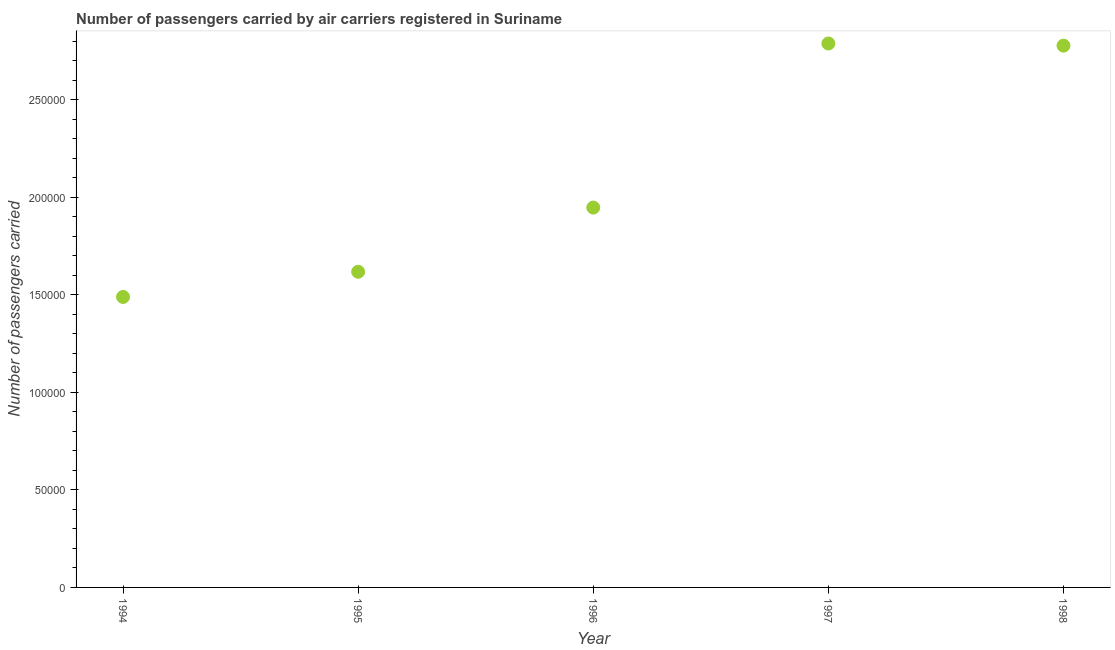What is the number of passengers carried in 1995?
Make the answer very short. 1.62e+05. Across all years, what is the maximum number of passengers carried?
Ensure brevity in your answer.  2.79e+05. Across all years, what is the minimum number of passengers carried?
Ensure brevity in your answer.  1.49e+05. In which year was the number of passengers carried maximum?
Keep it short and to the point. 1997. In which year was the number of passengers carried minimum?
Your response must be concise. 1994. What is the sum of the number of passengers carried?
Ensure brevity in your answer.  1.06e+06. What is the difference between the number of passengers carried in 1997 and 1998?
Ensure brevity in your answer.  1100. What is the average number of passengers carried per year?
Make the answer very short. 2.12e+05. What is the median number of passengers carried?
Your response must be concise. 1.95e+05. Do a majority of the years between 1996 and 1994 (inclusive) have number of passengers carried greater than 110000 ?
Give a very brief answer. No. What is the ratio of the number of passengers carried in 1994 to that in 1997?
Ensure brevity in your answer.  0.53. Is the number of passengers carried in 1997 less than that in 1998?
Offer a terse response. No. Is the difference between the number of passengers carried in 1995 and 1997 greater than the difference between any two years?
Your answer should be very brief. No. What is the difference between the highest and the second highest number of passengers carried?
Provide a succinct answer. 1100. What is the difference between the highest and the lowest number of passengers carried?
Give a very brief answer. 1.30e+05. In how many years, is the number of passengers carried greater than the average number of passengers carried taken over all years?
Provide a succinct answer. 2. Does the number of passengers carried monotonically increase over the years?
Provide a short and direct response. No. How many dotlines are there?
Provide a succinct answer. 1. How many years are there in the graph?
Give a very brief answer. 5. What is the difference between two consecutive major ticks on the Y-axis?
Give a very brief answer. 5.00e+04. Does the graph contain any zero values?
Ensure brevity in your answer.  No. What is the title of the graph?
Make the answer very short. Number of passengers carried by air carriers registered in Suriname. What is the label or title of the X-axis?
Your response must be concise. Year. What is the label or title of the Y-axis?
Make the answer very short. Number of passengers carried. What is the Number of passengers carried in 1994?
Your answer should be compact. 1.49e+05. What is the Number of passengers carried in 1995?
Keep it short and to the point. 1.62e+05. What is the Number of passengers carried in 1996?
Your answer should be compact. 1.95e+05. What is the Number of passengers carried in 1997?
Provide a succinct answer. 2.79e+05. What is the Number of passengers carried in 1998?
Give a very brief answer. 2.78e+05. What is the difference between the Number of passengers carried in 1994 and 1995?
Offer a very short reply. -1.29e+04. What is the difference between the Number of passengers carried in 1994 and 1996?
Provide a short and direct response. -4.58e+04. What is the difference between the Number of passengers carried in 1994 and 1997?
Your answer should be compact. -1.30e+05. What is the difference between the Number of passengers carried in 1994 and 1998?
Your response must be concise. -1.29e+05. What is the difference between the Number of passengers carried in 1995 and 1996?
Offer a terse response. -3.29e+04. What is the difference between the Number of passengers carried in 1995 and 1997?
Your answer should be compact. -1.17e+05. What is the difference between the Number of passengers carried in 1995 and 1998?
Offer a terse response. -1.16e+05. What is the difference between the Number of passengers carried in 1996 and 1997?
Provide a short and direct response. -8.41e+04. What is the difference between the Number of passengers carried in 1996 and 1998?
Give a very brief answer. -8.30e+04. What is the difference between the Number of passengers carried in 1997 and 1998?
Ensure brevity in your answer.  1100. What is the ratio of the Number of passengers carried in 1994 to that in 1996?
Provide a short and direct response. 0.77. What is the ratio of the Number of passengers carried in 1994 to that in 1997?
Offer a terse response. 0.53. What is the ratio of the Number of passengers carried in 1994 to that in 1998?
Your response must be concise. 0.54. What is the ratio of the Number of passengers carried in 1995 to that in 1996?
Your response must be concise. 0.83. What is the ratio of the Number of passengers carried in 1995 to that in 1997?
Your answer should be very brief. 0.58. What is the ratio of the Number of passengers carried in 1995 to that in 1998?
Your answer should be compact. 0.58. What is the ratio of the Number of passengers carried in 1996 to that in 1997?
Provide a short and direct response. 0.7. What is the ratio of the Number of passengers carried in 1996 to that in 1998?
Make the answer very short. 0.7. What is the ratio of the Number of passengers carried in 1997 to that in 1998?
Your response must be concise. 1. 